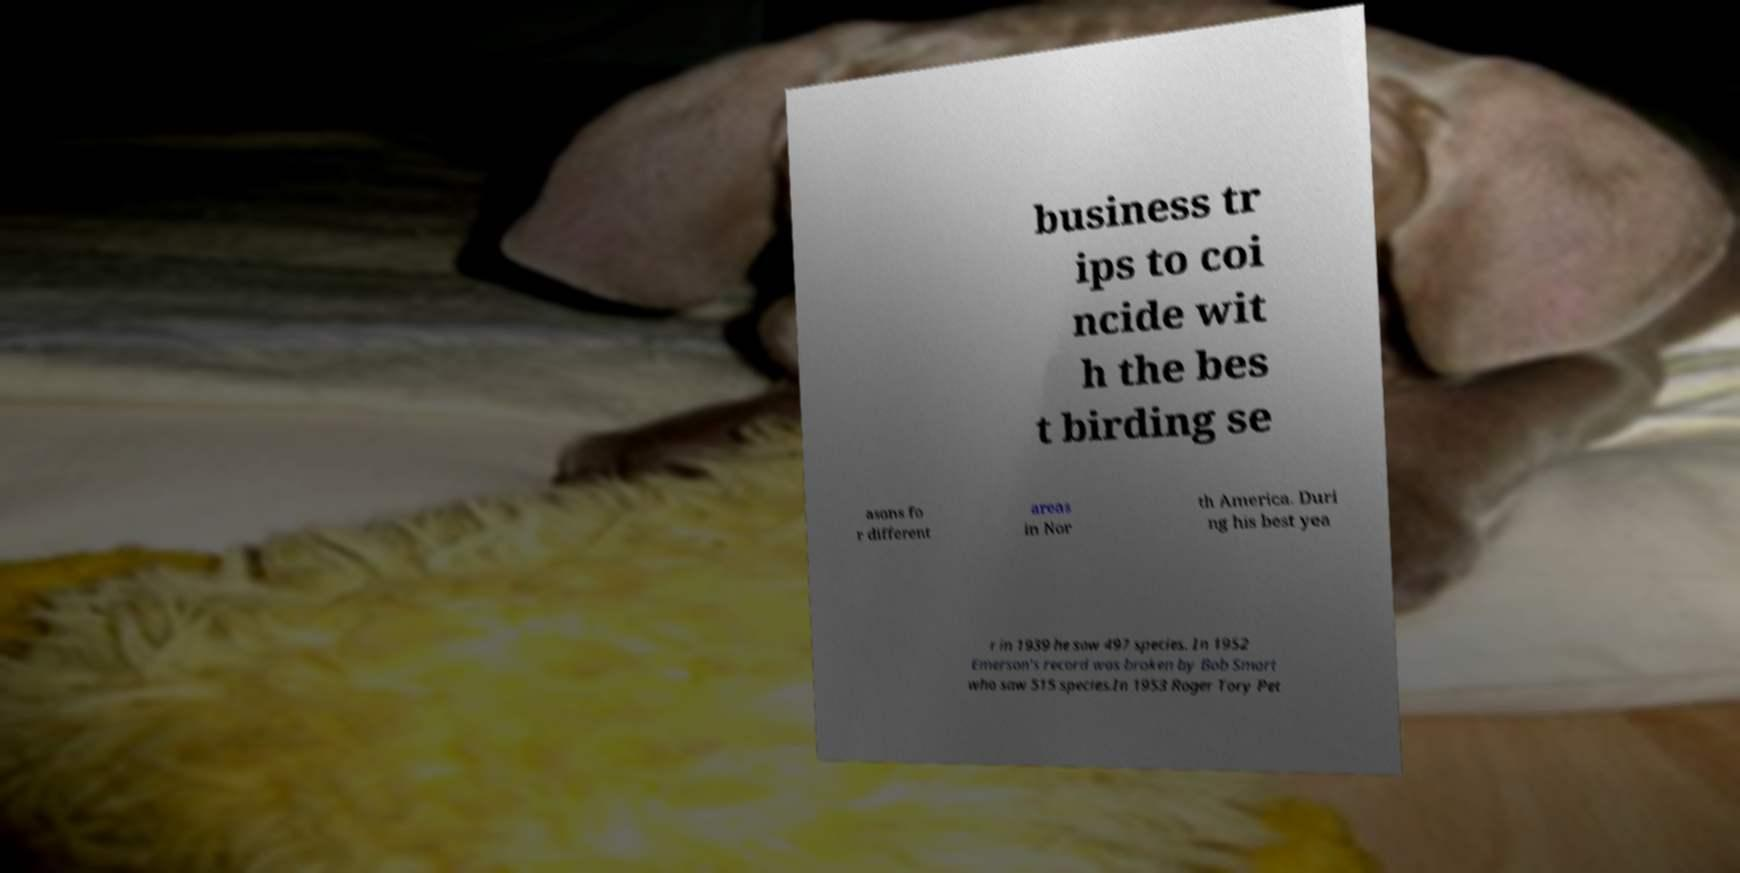Can you accurately transcribe the text from the provided image for me? business tr ips to coi ncide wit h the bes t birding se asons fo r different areas in Nor th America. Duri ng his best yea r in 1939 he saw 497 species. In 1952 Emerson's record was broken by Bob Smart who saw 515 species.In 1953 Roger Tory Pet 